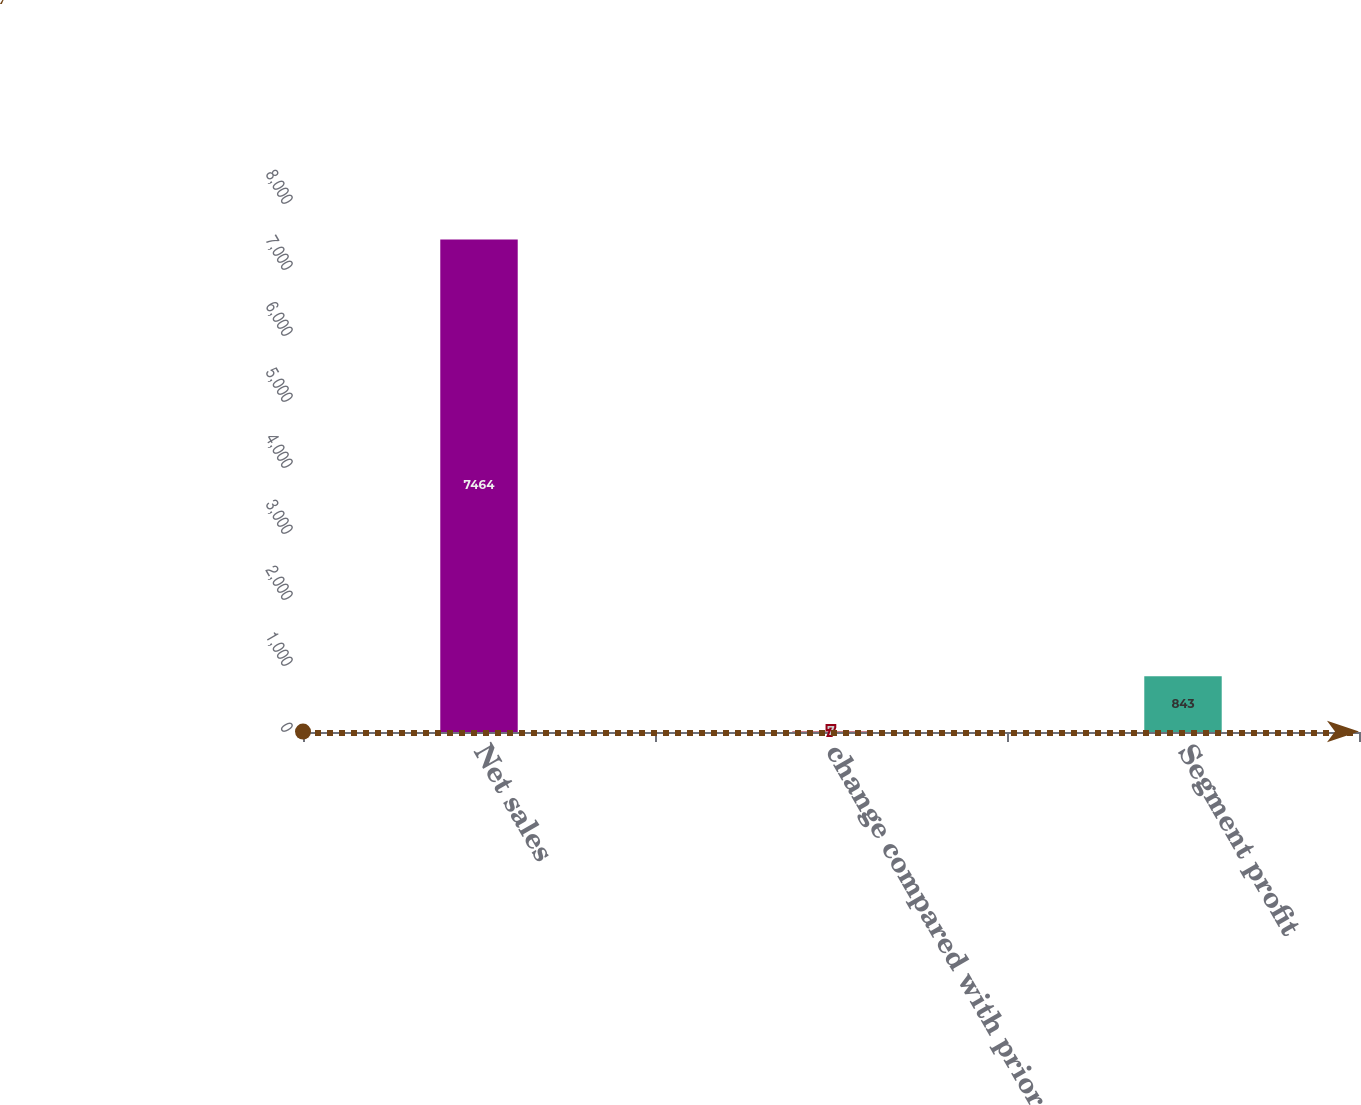Convert chart. <chart><loc_0><loc_0><loc_500><loc_500><bar_chart><fcel>Net sales<fcel>change compared with prior<fcel>Segment profit<nl><fcel>7464<fcel>7<fcel>843<nl></chart> 